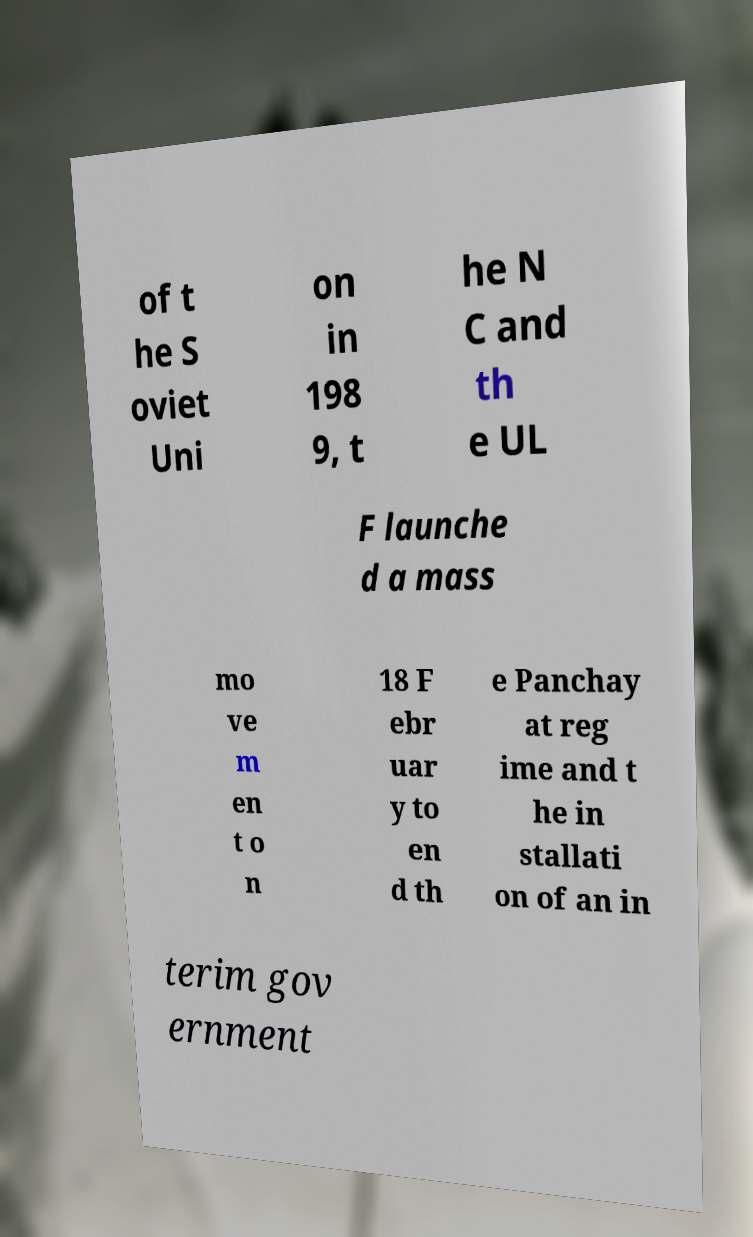Can you read and provide the text displayed in the image?This photo seems to have some interesting text. Can you extract and type it out for me? of t he S oviet Uni on in 198 9, t he N C and th e UL F launche d a mass mo ve m en t o n 18 F ebr uar y to en d th e Panchay at reg ime and t he in stallati on of an in terim gov ernment 